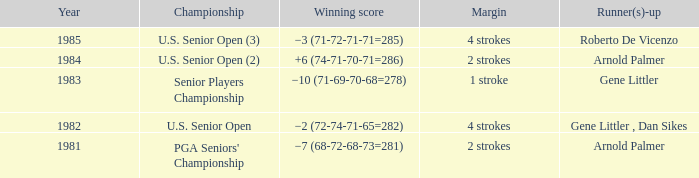Could you help me parse every detail presented in this table? {'header': ['Year', 'Championship', 'Winning score', 'Margin', 'Runner(s)-up'], 'rows': [['1985', 'U.S. Senior Open (3)', '−3 (71-72-71-71=285)', '4 strokes', 'Roberto De Vicenzo'], ['1984', 'U.S. Senior Open (2)', '+6 (74-71-70-71=286)', '2 strokes', 'Arnold Palmer'], ['1983', 'Senior Players Championship', '−10 (71-69-70-68=278)', '1 stroke', 'Gene Littler'], ['1982', 'U.S. Senior Open', '−2 (72-74-71-65=282)', '4 strokes', 'Gene Littler , Dan Sikes'], ['1981', "PGA Seniors' Championship", '−7 (68-72-68-73=281)', '2 strokes', 'Arnold Palmer']]} What championship was in 1985? U.S. Senior Open (3). 